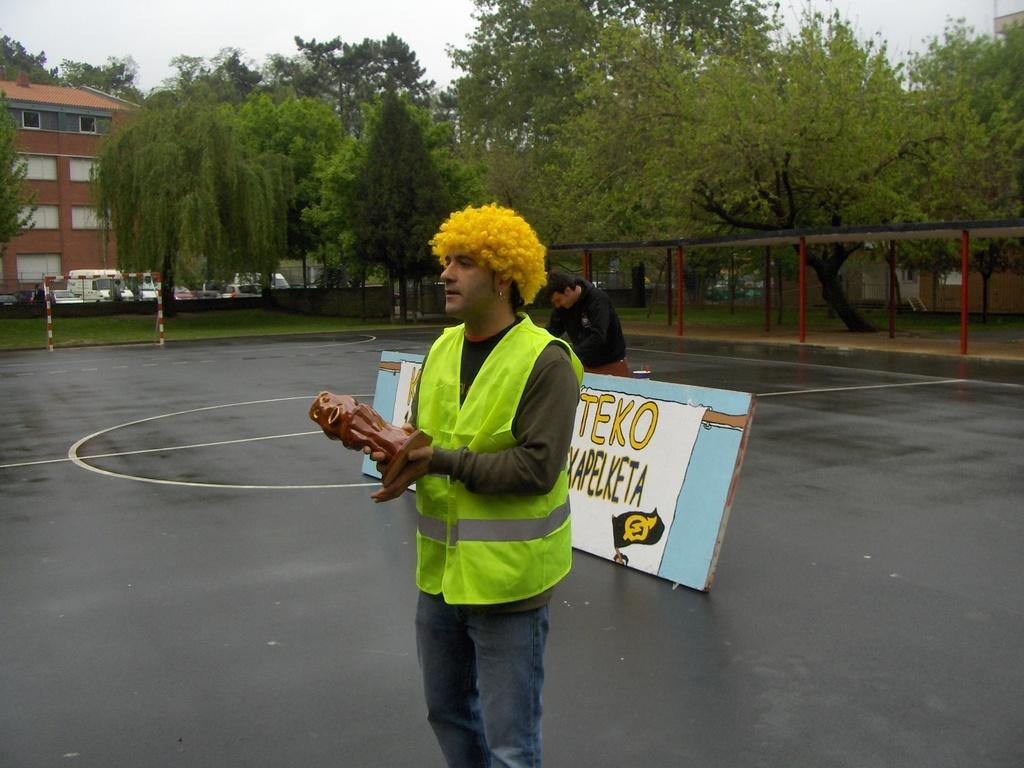In one or two sentences, can you explain what this image depicts? In this picture we can see a man holding a sculpture with his hands and at the back of him we can see a name board, person on the ground, grass, fences, trees, vehicles, poles, building and in the background we can see the sky. 